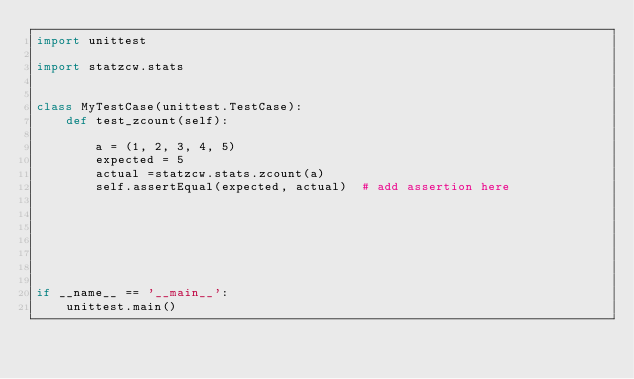Convert code to text. <code><loc_0><loc_0><loc_500><loc_500><_Python_>import unittest

import statzcw.stats


class MyTestCase(unittest.TestCase):
    def test_zcount(self):

        a = (1, 2, 3, 4, 5)
        expected = 5
        actual =statzcw.stats.zcount(a)
        self.assertEqual(expected, actual)  # add assertion here







if __name__ == '__main__':
    unittest.main()
</code> 